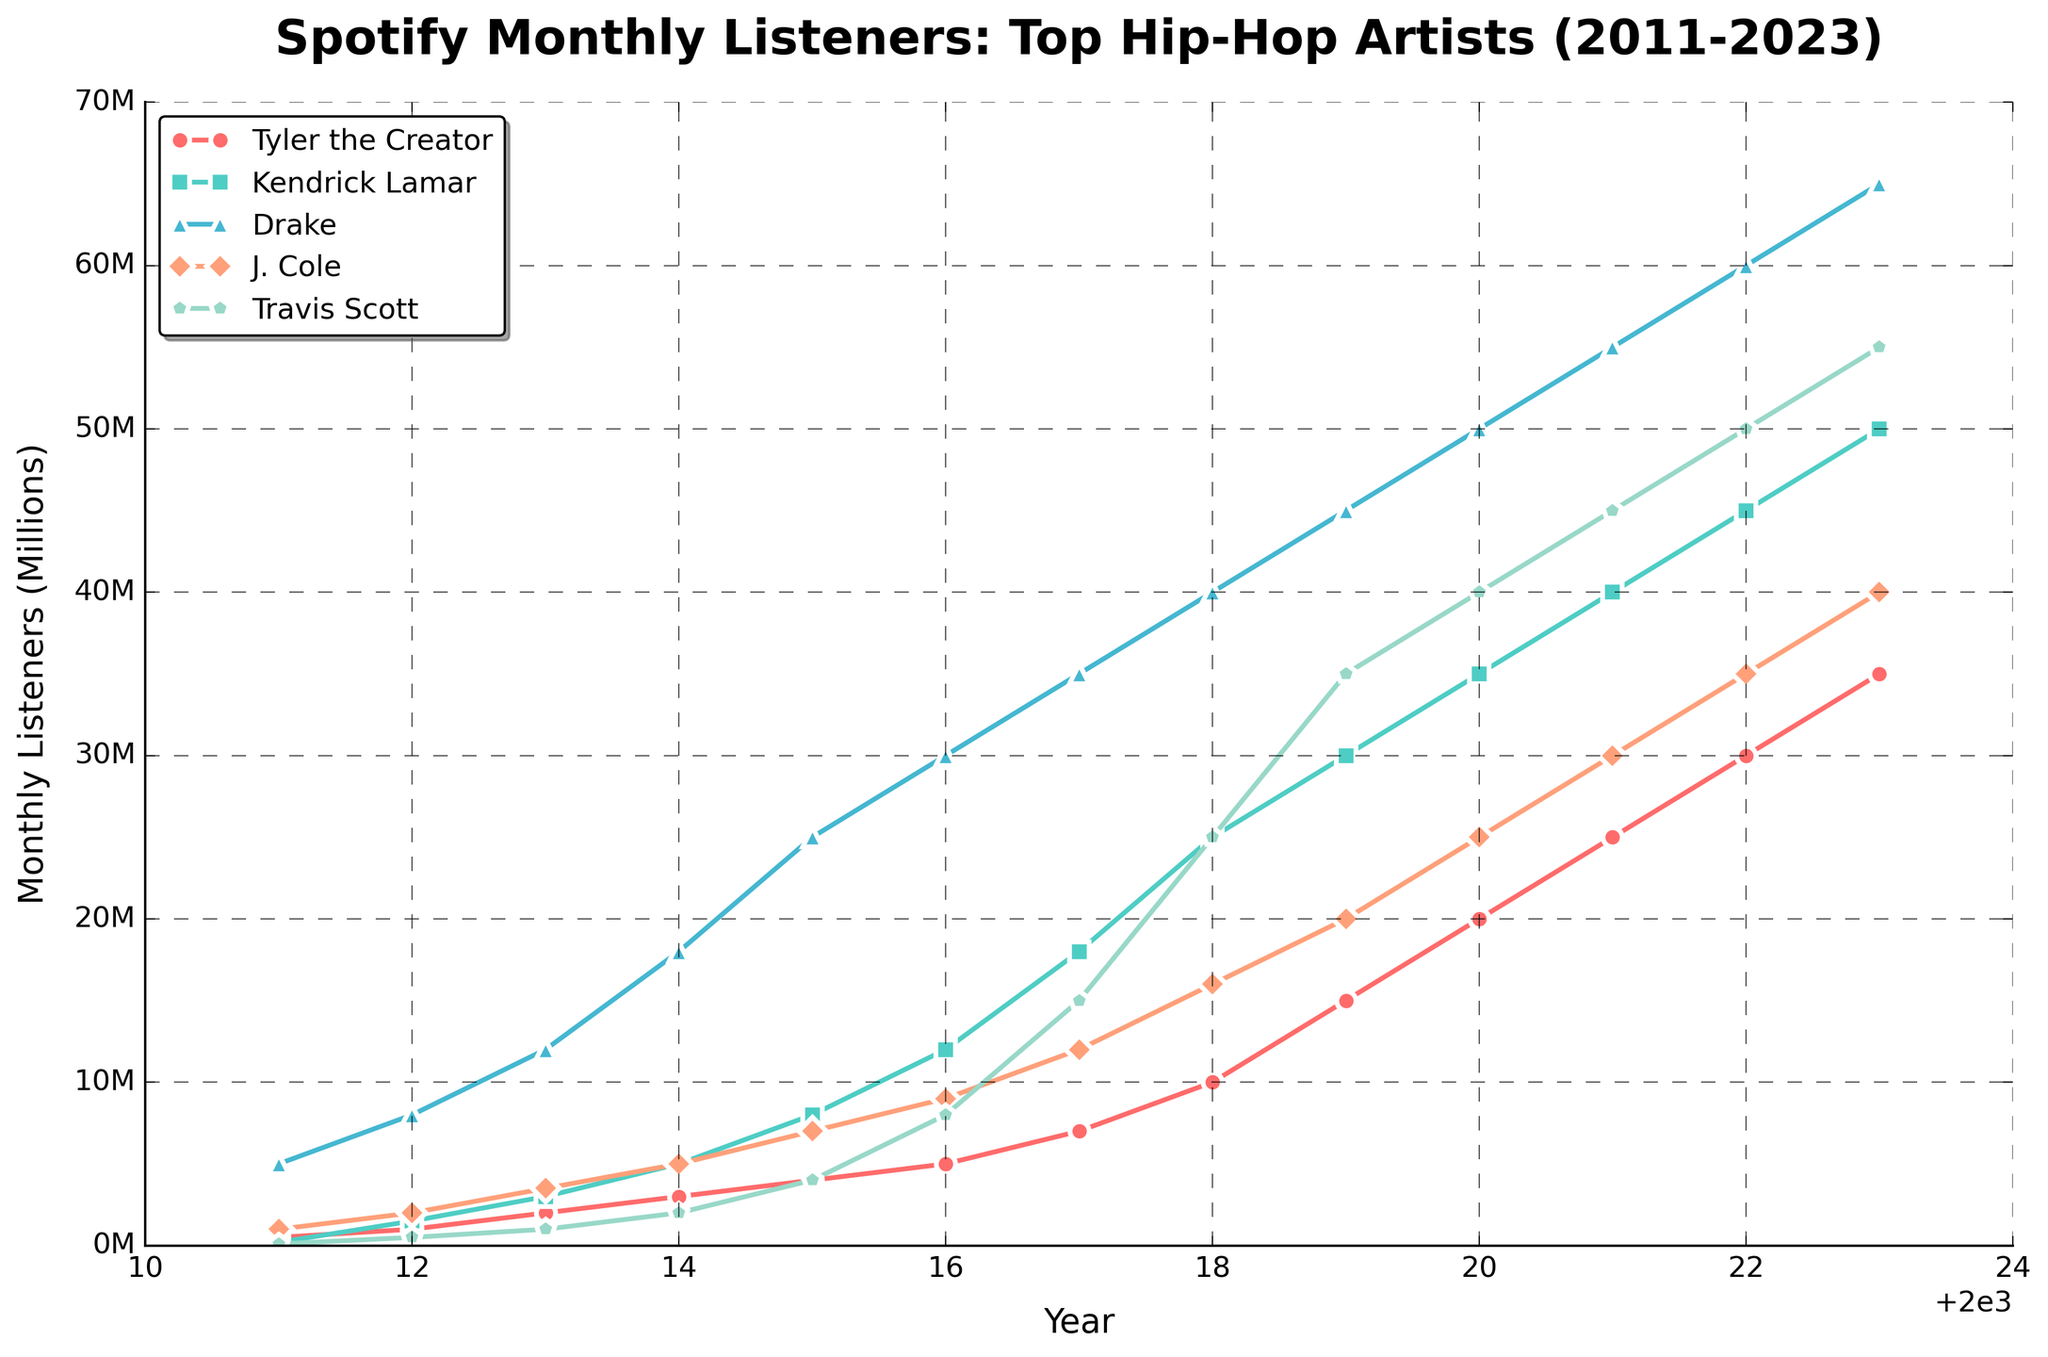What year did Tyler, the Creator surpass 10 million monthly listeners? Look at the data points for Tyler, the Creator and identify the year when the monthly listeners first exceed 10 million. Tyler’s listeners reach 10 million in 2018.
Answer: 2018 Which artist had the highest number of monthly listeners in 2014? Compare the monthly listener counts for all artists in the year 2014. Drake had the highest number with 18 million.
Answer: Drake By how much did Tyler, the Creator's listener count increase from 2011 to 2023? Calculate the difference in Tyler's monthly listener count between 2023 and 2011. 35,000,000 - 500,000 = 34,500,000.
Answer: 34,500,000 Who had more monthly listeners in 2023, Travis Scott or J. Cole? Look at the 2023 data points for both Travis Scott and J. Cole. Travis Scott had 55 million, while J. Cole had 40 million. Therefore, Travis Scott had more listeners.
Answer: Travis Scott What is the average monthly listener count for Drake between 2011 and 2023? Sum up Drake's monthly listeners from 2011 to 2023 and then divide by the number of years (13). (5M + 8M+ 12M + 18M + 25M + 30M + 35M + 40M + 45M + 50M + 55M + 60M + 65M) / 13 = 38,076,923
Answer: 38,076,923 In which year did Kendrick Lamar surpass J. Cole in monthly listeners for the first time? Compare the two artists’ monthly listeners year by year. Kendrick Lamar first surpassed J. Cole in 2012 with 1.5 million listeners compared to J. Cole's 2 million.
Answer: 2012 Which artist has the steepest upward trend in monthly listeners from 2011 to 2023? By observing the slope of the lines for each artist, identify whose line has the steepest rise. Drake's listener base grows the fastest, indicating he has the steepest upward trend.
Answer: Drake What is the difference in monthly listeners between Tyler, the Creator and Travis Scott in 2021? Look at the data for 2021 and calculate the difference. Tyler had 25 million and Travis had 45 million. Difference = 45 million - 25 million = 20 million.
Answer: 20 million Which artist shows the most significant increase in monthly listeners from 2019 to 2020? Calculate the difference for each artist between 2019 and 2020 and identify the most significant. Drake shows the most dramatic increase from 45 million to 50 million, an increase of 5 million.
Answer: Drake 